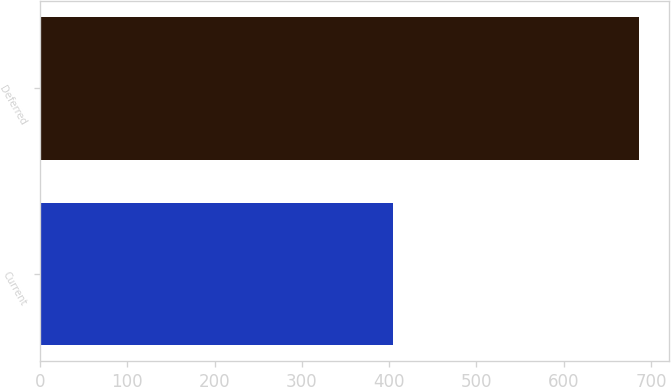Convert chart. <chart><loc_0><loc_0><loc_500><loc_500><bar_chart><fcel>Current<fcel>Deferred<nl><fcel>405<fcel>686<nl></chart> 